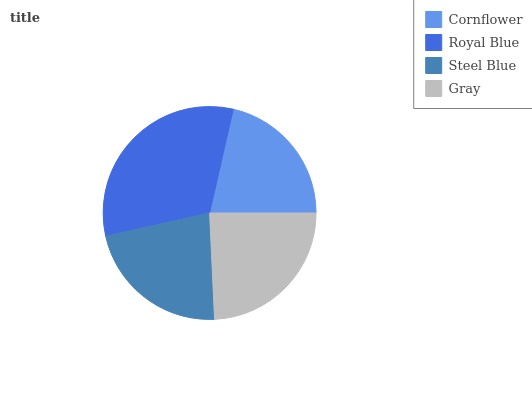Is Cornflower the minimum?
Answer yes or no. Yes. Is Royal Blue the maximum?
Answer yes or no. Yes. Is Steel Blue the minimum?
Answer yes or no. No. Is Steel Blue the maximum?
Answer yes or no. No. Is Royal Blue greater than Steel Blue?
Answer yes or no. Yes. Is Steel Blue less than Royal Blue?
Answer yes or no. Yes. Is Steel Blue greater than Royal Blue?
Answer yes or no. No. Is Royal Blue less than Steel Blue?
Answer yes or no. No. Is Gray the high median?
Answer yes or no. Yes. Is Steel Blue the low median?
Answer yes or no. Yes. Is Cornflower the high median?
Answer yes or no. No. Is Gray the low median?
Answer yes or no. No. 